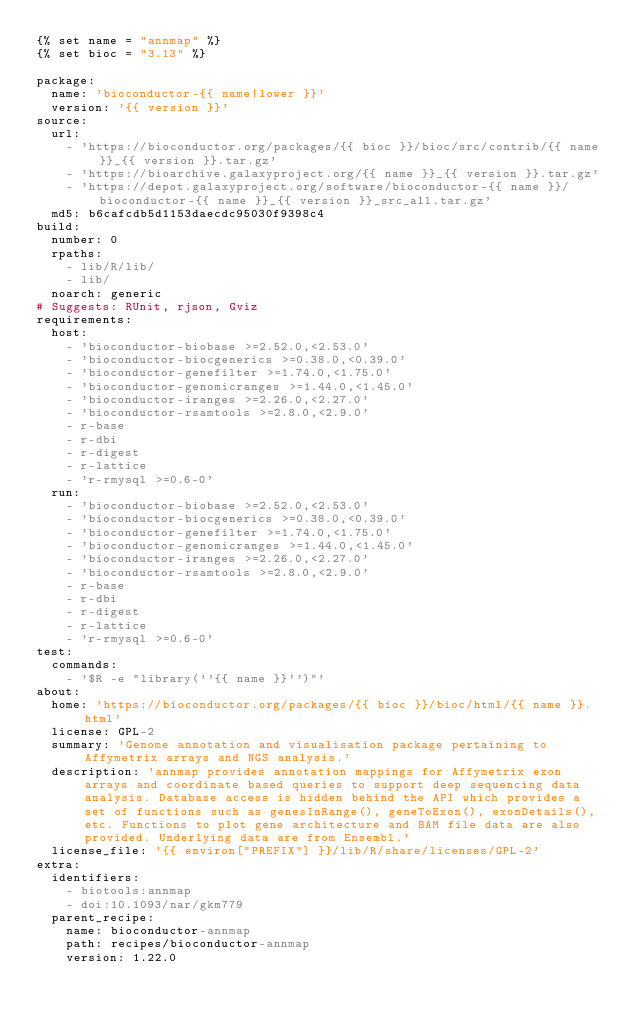Convert code to text. <code><loc_0><loc_0><loc_500><loc_500><_YAML_>{% set name = "annmap" %}
{% set bioc = "3.13" %}

package:
  name: 'bioconductor-{{ name|lower }}'
  version: '{{ version }}'
source:
  url:
    - 'https://bioconductor.org/packages/{{ bioc }}/bioc/src/contrib/{{ name }}_{{ version }}.tar.gz'
    - 'https://bioarchive.galaxyproject.org/{{ name }}_{{ version }}.tar.gz'
    - 'https://depot.galaxyproject.org/software/bioconductor-{{ name }}/bioconductor-{{ name }}_{{ version }}_src_all.tar.gz'
  md5: b6cafcdb5d1153daecdc95030f9398c4
build:
  number: 0
  rpaths:
    - lib/R/lib/
    - lib/
  noarch: generic
# Suggests: RUnit, rjson, Gviz
requirements:
  host:
    - 'bioconductor-biobase >=2.52.0,<2.53.0'
    - 'bioconductor-biocgenerics >=0.38.0,<0.39.0'
    - 'bioconductor-genefilter >=1.74.0,<1.75.0'
    - 'bioconductor-genomicranges >=1.44.0,<1.45.0'
    - 'bioconductor-iranges >=2.26.0,<2.27.0'
    - 'bioconductor-rsamtools >=2.8.0,<2.9.0'
    - r-base
    - r-dbi
    - r-digest
    - r-lattice
    - 'r-rmysql >=0.6-0'
  run:
    - 'bioconductor-biobase >=2.52.0,<2.53.0'
    - 'bioconductor-biocgenerics >=0.38.0,<0.39.0'
    - 'bioconductor-genefilter >=1.74.0,<1.75.0'
    - 'bioconductor-genomicranges >=1.44.0,<1.45.0'
    - 'bioconductor-iranges >=2.26.0,<2.27.0'
    - 'bioconductor-rsamtools >=2.8.0,<2.9.0'
    - r-base
    - r-dbi
    - r-digest
    - r-lattice
    - 'r-rmysql >=0.6-0'
test:
  commands:
    - '$R -e "library(''{{ name }}'')"'
about:
  home: 'https://bioconductor.org/packages/{{ bioc }}/bioc/html/{{ name }}.html'
  license: GPL-2
  summary: 'Genome annotation and visualisation package pertaining to Affymetrix arrays and NGS analysis.'
  description: 'annmap provides annotation mappings for Affymetrix exon arrays and coordinate based queries to support deep sequencing data analysis. Database access is hidden behind the API which provides a set of functions such as genesInRange(), geneToExon(), exonDetails(), etc. Functions to plot gene architecture and BAM file data are also provided. Underlying data are from Ensembl.'
  license_file: '{{ environ["PREFIX"] }}/lib/R/share/licenses/GPL-2'
extra:
  identifiers:
    - biotools:annmap
    - doi:10.1093/nar/gkm779
  parent_recipe:
    name: bioconductor-annmap
    path: recipes/bioconductor-annmap
    version: 1.22.0

</code> 